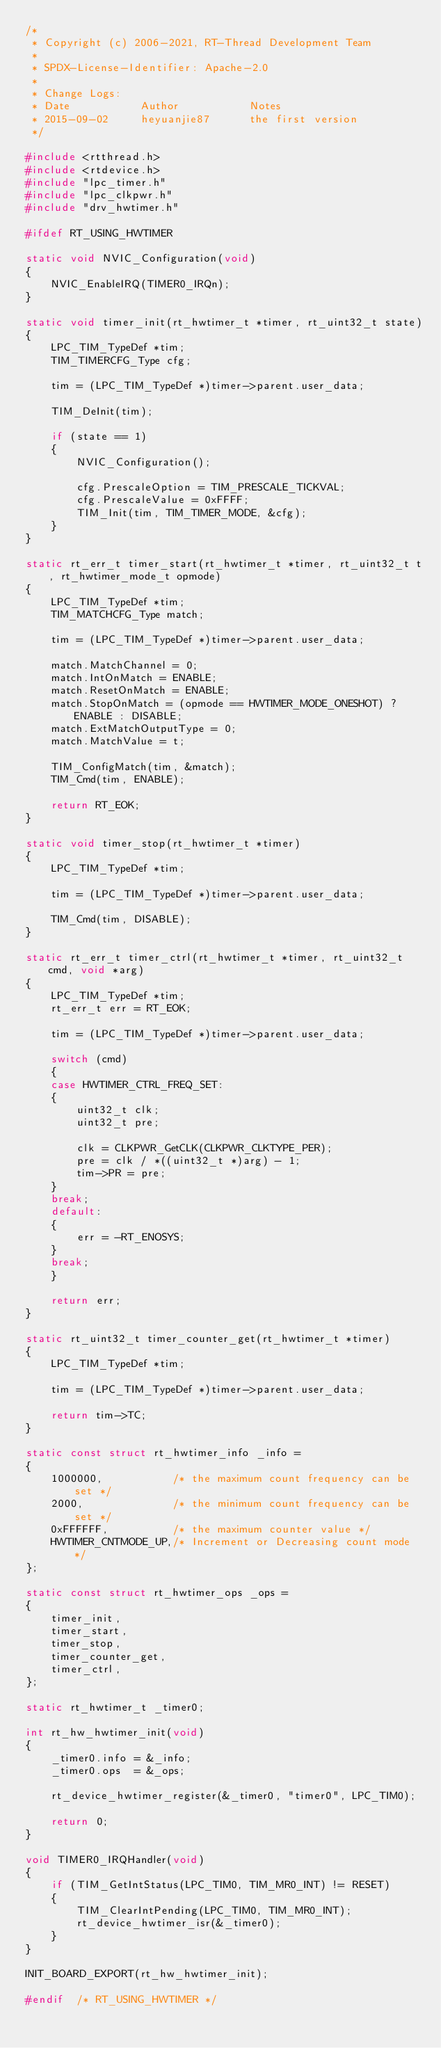Convert code to text. <code><loc_0><loc_0><loc_500><loc_500><_C_>/*
 * Copyright (c) 2006-2021, RT-Thread Development Team
 *
 * SPDX-License-Identifier: Apache-2.0
 *
 * Change Logs:
 * Date           Author           Notes
 * 2015-09-02     heyuanjie87      the first version
 */

#include <rtthread.h>
#include <rtdevice.h>
#include "lpc_timer.h"
#include "lpc_clkpwr.h"
#include "drv_hwtimer.h"

#ifdef RT_USING_HWTIMER

static void NVIC_Configuration(void)
{
    NVIC_EnableIRQ(TIMER0_IRQn);
}

static void timer_init(rt_hwtimer_t *timer, rt_uint32_t state)
{
    LPC_TIM_TypeDef *tim;
    TIM_TIMERCFG_Type cfg;

    tim = (LPC_TIM_TypeDef *)timer->parent.user_data;

    TIM_DeInit(tim);

    if (state == 1)
    {
        NVIC_Configuration();

        cfg.PrescaleOption = TIM_PRESCALE_TICKVAL;
        cfg.PrescaleValue = 0xFFFF;
        TIM_Init(tim, TIM_TIMER_MODE, &cfg);
    }
}

static rt_err_t timer_start(rt_hwtimer_t *timer, rt_uint32_t t, rt_hwtimer_mode_t opmode)
{
    LPC_TIM_TypeDef *tim;
    TIM_MATCHCFG_Type match;

    tim = (LPC_TIM_TypeDef *)timer->parent.user_data;

    match.MatchChannel = 0;
    match.IntOnMatch = ENABLE;
    match.ResetOnMatch = ENABLE;
    match.StopOnMatch = (opmode == HWTIMER_MODE_ONESHOT) ? ENABLE : DISABLE;
    match.ExtMatchOutputType = 0;
    match.MatchValue = t;

    TIM_ConfigMatch(tim, &match);
    TIM_Cmd(tim, ENABLE);

    return RT_EOK;
}

static void timer_stop(rt_hwtimer_t *timer)
{
    LPC_TIM_TypeDef *tim;

    tim = (LPC_TIM_TypeDef *)timer->parent.user_data;

    TIM_Cmd(tim, DISABLE);
}

static rt_err_t timer_ctrl(rt_hwtimer_t *timer, rt_uint32_t cmd, void *arg)
{
    LPC_TIM_TypeDef *tim;
    rt_err_t err = RT_EOK;

    tim = (LPC_TIM_TypeDef *)timer->parent.user_data;

    switch (cmd)
    {
    case HWTIMER_CTRL_FREQ_SET:
    {
        uint32_t clk;
        uint32_t pre;

        clk = CLKPWR_GetCLK(CLKPWR_CLKTYPE_PER);
        pre = clk / *((uint32_t *)arg) - 1;
        tim->PR = pre;
    }
    break;
    default:
    {
        err = -RT_ENOSYS;
    }
    break;
    }

    return err;
}

static rt_uint32_t timer_counter_get(rt_hwtimer_t *timer)
{
    LPC_TIM_TypeDef *tim;

    tim = (LPC_TIM_TypeDef *)timer->parent.user_data;

    return tim->TC;
}

static const struct rt_hwtimer_info _info =
{
    1000000,           /* the maximum count frequency can be set */
    2000,              /* the minimum count frequency can be set */
    0xFFFFFF,          /* the maximum counter value */
    HWTIMER_CNTMODE_UP,/* Increment or Decreasing count mode */
};

static const struct rt_hwtimer_ops _ops =
{
    timer_init,
    timer_start,
    timer_stop,
    timer_counter_get,
    timer_ctrl,
};

static rt_hwtimer_t _timer0;

int rt_hw_hwtimer_init(void)
{
    _timer0.info = &_info;
    _timer0.ops  = &_ops;

    rt_device_hwtimer_register(&_timer0, "timer0", LPC_TIM0);

    return 0;
}

void TIMER0_IRQHandler(void)
{
    if (TIM_GetIntStatus(LPC_TIM0, TIM_MR0_INT) != RESET)
    {
        TIM_ClearIntPending(LPC_TIM0, TIM_MR0_INT);
        rt_device_hwtimer_isr(&_timer0);
    }
}

INIT_BOARD_EXPORT(rt_hw_hwtimer_init);

#endif  /* RT_USING_HWTIMER */
</code> 